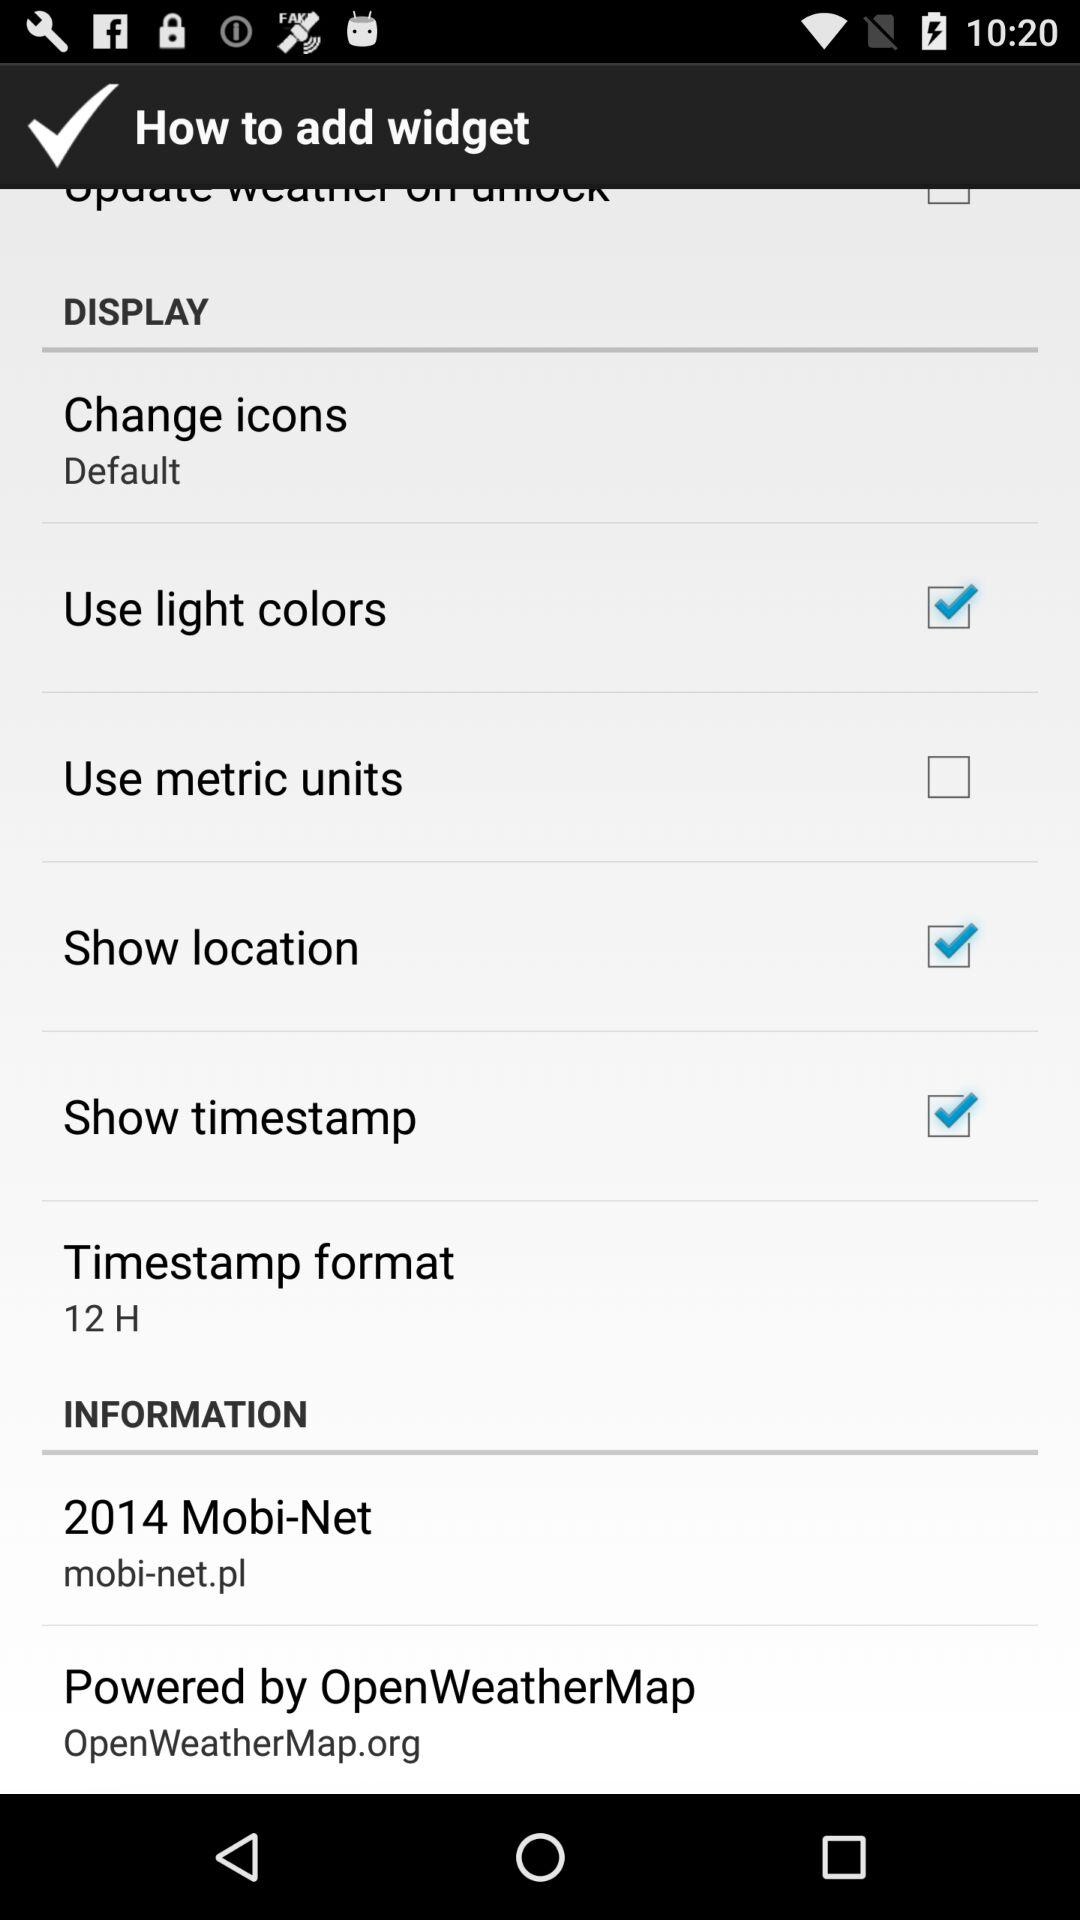What is the timestamp format? The timestamp format is "12 H". 